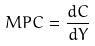Convert formula to latex. <formula><loc_0><loc_0><loc_500><loc_500>M P C = \frac { d C } { d Y }</formula> 